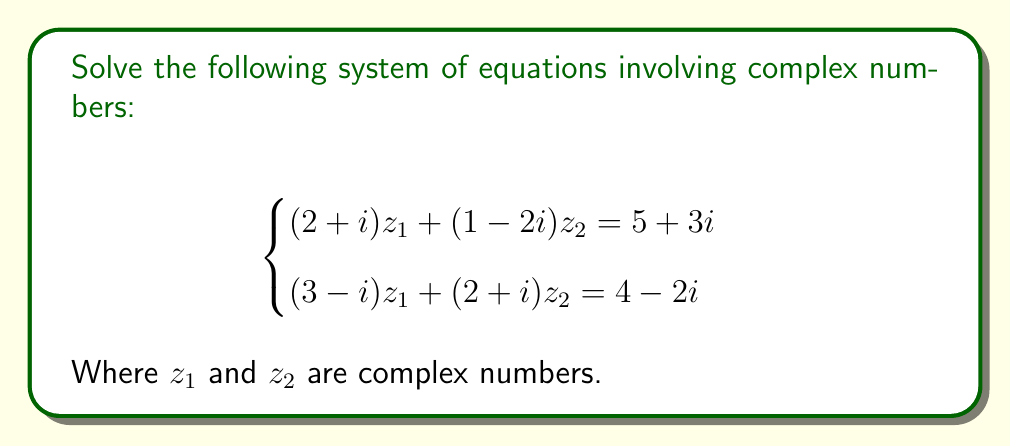Could you help me with this problem? Let's solve this system step by step:

1) First, we'll treat this as a system of linear equations with complex coefficients. We can use the elimination method.

2) Multiply the first equation by $(3-i)$ and the second equation by $(2+i)$:

   $$(3-i)[(2+i)z_1 + (1-2i)z_2 = 5+3i]$$
   $$(2+i)[(3-i)z_1 + (2+i)z_2 = 4-2i]$$

3) Expanding these equations:

   $$(6-3i+2i-i^2)z_1 + (3-i-6i+2i^2)z_2 = 15+9i-5i-3i^2$$
   $$(6-2i+3i+i^2)z_1 + (4+2i+2i-i^2)z_2 = 8-4i+4i+2i^2$$

4) Simplify, remembering that $i^2 = -1$:

   $$(7+i)z_1 + (5-7i)z_2 = 18+4i$$
   $$(5+i)z_1 + (5+i)z_2 = 10$$

5) Subtracting the second equation from the first:

   $$2z_1 + (-8i)z_2 = 8+4i$$

6) Divide by 2:

   $$z_1 - 4iz_2 = 4+2i$$

7) Substitute this expression for $z_1$ into the second equation from step 4:

   $$(5+i)(4+2i+4iz_2) + (5+i)z_2 = 10$$

8) Expand:

   $$20+10i+8i+4i^2+20iz_2+5iz_2 + 5z_2+iz_2 = 10$$

9) Simplify:

   $$16+18i+(25+26i)z_2 = 10$$

10) Subtract 16 from both sides:

    $$18i+(25+26i)z_2 = -6$$

11) Separate real and imaginary parts:

    $$25z_2 = -6$$
    $$18+26z_2 = 0$$

12) From the first equation: $z_2 = -\frac{6}{25}$

13) Substitute this into the expression for $z_1$ from step 6:

    $$z_1 = 4+2i+4i(-\frac{6}{25}) = 4+2i-\frac{24i}{25} = 4+\frac{26i}{25}$$

Therefore, $z_1 = 4+\frac{26i}{25}$ and $z_2 = -\frac{6}{25}$.
Answer: $z_1 = 4+\frac{26i}{25}$, $z_2 = -\frac{6}{25}$ 